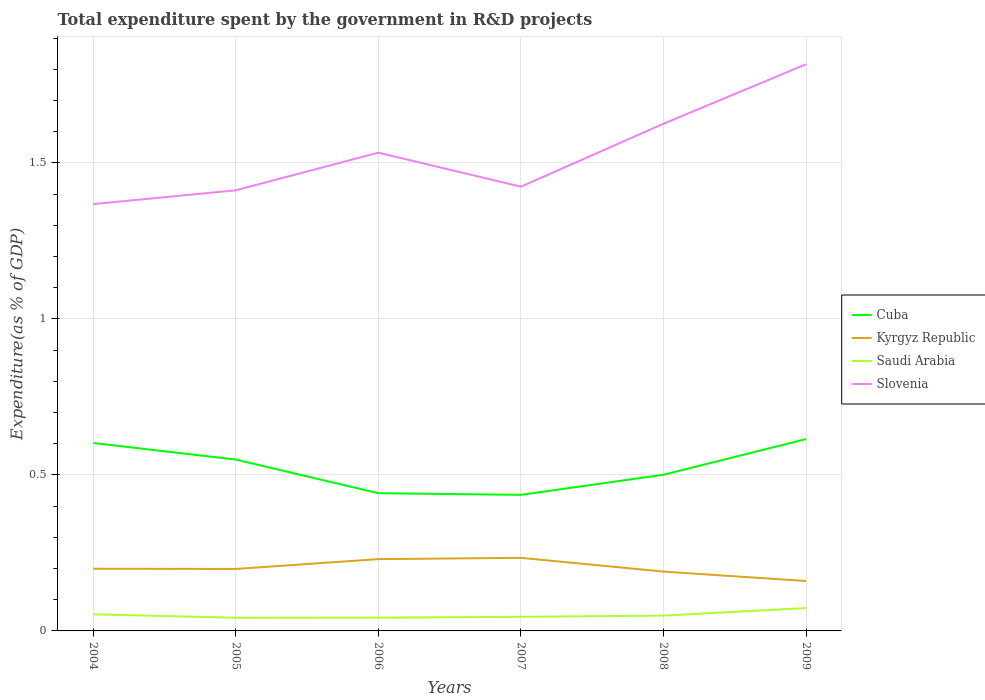Does the line corresponding to Saudi Arabia intersect with the line corresponding to Kyrgyz Republic?
Keep it short and to the point. No. Is the number of lines equal to the number of legend labels?
Make the answer very short. Yes. Across all years, what is the maximum total expenditure spent by the government in R&D projects in Saudi Arabia?
Provide a short and direct response. 0.04. What is the total total expenditure spent by the government in R&D projects in Saudi Arabia in the graph?
Provide a succinct answer. 0.01. What is the difference between the highest and the second highest total expenditure spent by the government in R&D projects in Kyrgyz Republic?
Keep it short and to the point. 0.07. Is the total expenditure spent by the government in R&D projects in Slovenia strictly greater than the total expenditure spent by the government in R&D projects in Cuba over the years?
Make the answer very short. No. How many years are there in the graph?
Ensure brevity in your answer.  6. What is the difference between two consecutive major ticks on the Y-axis?
Offer a very short reply. 0.5. Are the values on the major ticks of Y-axis written in scientific E-notation?
Your answer should be compact. No. Does the graph contain grids?
Your response must be concise. Yes. Where does the legend appear in the graph?
Provide a short and direct response. Center right. How many legend labels are there?
Your answer should be compact. 4. What is the title of the graph?
Give a very brief answer. Total expenditure spent by the government in R&D projects. Does "Kosovo" appear as one of the legend labels in the graph?
Make the answer very short. No. What is the label or title of the Y-axis?
Your response must be concise. Expenditure(as % of GDP). What is the Expenditure(as % of GDP) in Cuba in 2004?
Provide a short and direct response. 0.6. What is the Expenditure(as % of GDP) of Kyrgyz Republic in 2004?
Keep it short and to the point. 0.2. What is the Expenditure(as % of GDP) in Saudi Arabia in 2004?
Make the answer very short. 0.05. What is the Expenditure(as % of GDP) in Slovenia in 2004?
Your response must be concise. 1.37. What is the Expenditure(as % of GDP) in Cuba in 2005?
Offer a terse response. 0.55. What is the Expenditure(as % of GDP) in Kyrgyz Republic in 2005?
Offer a terse response. 0.2. What is the Expenditure(as % of GDP) of Saudi Arabia in 2005?
Your answer should be very brief. 0.04. What is the Expenditure(as % of GDP) of Slovenia in 2005?
Offer a terse response. 1.41. What is the Expenditure(as % of GDP) of Cuba in 2006?
Your answer should be compact. 0.44. What is the Expenditure(as % of GDP) in Kyrgyz Republic in 2006?
Give a very brief answer. 0.23. What is the Expenditure(as % of GDP) of Saudi Arabia in 2006?
Ensure brevity in your answer.  0.04. What is the Expenditure(as % of GDP) of Slovenia in 2006?
Give a very brief answer. 1.53. What is the Expenditure(as % of GDP) in Cuba in 2007?
Make the answer very short. 0.44. What is the Expenditure(as % of GDP) of Kyrgyz Republic in 2007?
Your answer should be very brief. 0.23. What is the Expenditure(as % of GDP) of Saudi Arabia in 2007?
Offer a very short reply. 0.05. What is the Expenditure(as % of GDP) in Slovenia in 2007?
Ensure brevity in your answer.  1.42. What is the Expenditure(as % of GDP) in Cuba in 2008?
Make the answer very short. 0.5. What is the Expenditure(as % of GDP) in Kyrgyz Republic in 2008?
Offer a terse response. 0.19. What is the Expenditure(as % of GDP) in Saudi Arabia in 2008?
Ensure brevity in your answer.  0.05. What is the Expenditure(as % of GDP) of Slovenia in 2008?
Provide a short and direct response. 1.63. What is the Expenditure(as % of GDP) of Cuba in 2009?
Provide a succinct answer. 0.61. What is the Expenditure(as % of GDP) of Kyrgyz Republic in 2009?
Offer a terse response. 0.16. What is the Expenditure(as % of GDP) of Saudi Arabia in 2009?
Ensure brevity in your answer.  0.07. What is the Expenditure(as % of GDP) of Slovenia in 2009?
Make the answer very short. 1.82. Across all years, what is the maximum Expenditure(as % of GDP) of Cuba?
Give a very brief answer. 0.61. Across all years, what is the maximum Expenditure(as % of GDP) of Kyrgyz Republic?
Offer a very short reply. 0.23. Across all years, what is the maximum Expenditure(as % of GDP) in Saudi Arabia?
Your answer should be very brief. 0.07. Across all years, what is the maximum Expenditure(as % of GDP) in Slovenia?
Provide a succinct answer. 1.82. Across all years, what is the minimum Expenditure(as % of GDP) in Cuba?
Provide a short and direct response. 0.44. Across all years, what is the minimum Expenditure(as % of GDP) in Kyrgyz Republic?
Keep it short and to the point. 0.16. Across all years, what is the minimum Expenditure(as % of GDP) of Saudi Arabia?
Provide a succinct answer. 0.04. Across all years, what is the minimum Expenditure(as % of GDP) in Slovenia?
Provide a succinct answer. 1.37. What is the total Expenditure(as % of GDP) in Cuba in the graph?
Your answer should be very brief. 3.14. What is the total Expenditure(as % of GDP) of Kyrgyz Republic in the graph?
Offer a very short reply. 1.21. What is the total Expenditure(as % of GDP) in Saudi Arabia in the graph?
Keep it short and to the point. 0.31. What is the total Expenditure(as % of GDP) of Slovenia in the graph?
Give a very brief answer. 9.18. What is the difference between the Expenditure(as % of GDP) of Cuba in 2004 and that in 2005?
Your answer should be compact. 0.05. What is the difference between the Expenditure(as % of GDP) in Kyrgyz Republic in 2004 and that in 2005?
Offer a very short reply. 0. What is the difference between the Expenditure(as % of GDP) of Saudi Arabia in 2004 and that in 2005?
Offer a terse response. 0.01. What is the difference between the Expenditure(as % of GDP) of Slovenia in 2004 and that in 2005?
Ensure brevity in your answer.  -0.04. What is the difference between the Expenditure(as % of GDP) in Cuba in 2004 and that in 2006?
Offer a terse response. 0.16. What is the difference between the Expenditure(as % of GDP) of Kyrgyz Republic in 2004 and that in 2006?
Give a very brief answer. -0.03. What is the difference between the Expenditure(as % of GDP) in Saudi Arabia in 2004 and that in 2006?
Ensure brevity in your answer.  0.01. What is the difference between the Expenditure(as % of GDP) of Slovenia in 2004 and that in 2006?
Offer a very short reply. -0.16. What is the difference between the Expenditure(as % of GDP) of Cuba in 2004 and that in 2007?
Give a very brief answer. 0.17. What is the difference between the Expenditure(as % of GDP) in Kyrgyz Republic in 2004 and that in 2007?
Give a very brief answer. -0.04. What is the difference between the Expenditure(as % of GDP) in Saudi Arabia in 2004 and that in 2007?
Offer a very short reply. 0.01. What is the difference between the Expenditure(as % of GDP) of Slovenia in 2004 and that in 2007?
Make the answer very short. -0.06. What is the difference between the Expenditure(as % of GDP) in Cuba in 2004 and that in 2008?
Provide a short and direct response. 0.1. What is the difference between the Expenditure(as % of GDP) in Kyrgyz Republic in 2004 and that in 2008?
Make the answer very short. 0.01. What is the difference between the Expenditure(as % of GDP) in Saudi Arabia in 2004 and that in 2008?
Ensure brevity in your answer.  0. What is the difference between the Expenditure(as % of GDP) of Slovenia in 2004 and that in 2008?
Provide a succinct answer. -0.26. What is the difference between the Expenditure(as % of GDP) of Cuba in 2004 and that in 2009?
Your answer should be very brief. -0.01. What is the difference between the Expenditure(as % of GDP) in Kyrgyz Republic in 2004 and that in 2009?
Your answer should be very brief. 0.04. What is the difference between the Expenditure(as % of GDP) of Saudi Arabia in 2004 and that in 2009?
Your response must be concise. -0.02. What is the difference between the Expenditure(as % of GDP) in Slovenia in 2004 and that in 2009?
Ensure brevity in your answer.  -0.45. What is the difference between the Expenditure(as % of GDP) of Cuba in 2005 and that in 2006?
Your answer should be very brief. 0.11. What is the difference between the Expenditure(as % of GDP) in Kyrgyz Republic in 2005 and that in 2006?
Give a very brief answer. -0.03. What is the difference between the Expenditure(as % of GDP) in Saudi Arabia in 2005 and that in 2006?
Your answer should be very brief. -0. What is the difference between the Expenditure(as % of GDP) of Slovenia in 2005 and that in 2006?
Give a very brief answer. -0.12. What is the difference between the Expenditure(as % of GDP) of Cuba in 2005 and that in 2007?
Your answer should be very brief. 0.11. What is the difference between the Expenditure(as % of GDP) of Kyrgyz Republic in 2005 and that in 2007?
Give a very brief answer. -0.04. What is the difference between the Expenditure(as % of GDP) in Saudi Arabia in 2005 and that in 2007?
Provide a succinct answer. -0. What is the difference between the Expenditure(as % of GDP) in Slovenia in 2005 and that in 2007?
Give a very brief answer. -0.01. What is the difference between the Expenditure(as % of GDP) of Cuba in 2005 and that in 2008?
Provide a succinct answer. 0.05. What is the difference between the Expenditure(as % of GDP) of Kyrgyz Republic in 2005 and that in 2008?
Your response must be concise. 0.01. What is the difference between the Expenditure(as % of GDP) in Saudi Arabia in 2005 and that in 2008?
Offer a very short reply. -0.01. What is the difference between the Expenditure(as % of GDP) of Slovenia in 2005 and that in 2008?
Your answer should be compact. -0.21. What is the difference between the Expenditure(as % of GDP) in Cuba in 2005 and that in 2009?
Your answer should be very brief. -0.07. What is the difference between the Expenditure(as % of GDP) of Kyrgyz Republic in 2005 and that in 2009?
Keep it short and to the point. 0.04. What is the difference between the Expenditure(as % of GDP) of Saudi Arabia in 2005 and that in 2009?
Provide a succinct answer. -0.03. What is the difference between the Expenditure(as % of GDP) of Slovenia in 2005 and that in 2009?
Your response must be concise. -0.4. What is the difference between the Expenditure(as % of GDP) in Cuba in 2006 and that in 2007?
Provide a succinct answer. 0.01. What is the difference between the Expenditure(as % of GDP) of Kyrgyz Republic in 2006 and that in 2007?
Offer a terse response. -0. What is the difference between the Expenditure(as % of GDP) of Saudi Arabia in 2006 and that in 2007?
Give a very brief answer. -0. What is the difference between the Expenditure(as % of GDP) of Slovenia in 2006 and that in 2007?
Make the answer very short. 0.11. What is the difference between the Expenditure(as % of GDP) of Cuba in 2006 and that in 2008?
Your response must be concise. -0.06. What is the difference between the Expenditure(as % of GDP) in Saudi Arabia in 2006 and that in 2008?
Provide a short and direct response. -0.01. What is the difference between the Expenditure(as % of GDP) in Slovenia in 2006 and that in 2008?
Provide a short and direct response. -0.09. What is the difference between the Expenditure(as % of GDP) in Cuba in 2006 and that in 2009?
Your answer should be very brief. -0.17. What is the difference between the Expenditure(as % of GDP) in Kyrgyz Republic in 2006 and that in 2009?
Provide a short and direct response. 0.07. What is the difference between the Expenditure(as % of GDP) in Saudi Arabia in 2006 and that in 2009?
Ensure brevity in your answer.  -0.03. What is the difference between the Expenditure(as % of GDP) in Slovenia in 2006 and that in 2009?
Ensure brevity in your answer.  -0.28. What is the difference between the Expenditure(as % of GDP) of Cuba in 2007 and that in 2008?
Give a very brief answer. -0.06. What is the difference between the Expenditure(as % of GDP) in Kyrgyz Republic in 2007 and that in 2008?
Offer a terse response. 0.04. What is the difference between the Expenditure(as % of GDP) in Saudi Arabia in 2007 and that in 2008?
Give a very brief answer. -0. What is the difference between the Expenditure(as % of GDP) of Slovenia in 2007 and that in 2008?
Provide a succinct answer. -0.2. What is the difference between the Expenditure(as % of GDP) in Cuba in 2007 and that in 2009?
Ensure brevity in your answer.  -0.18. What is the difference between the Expenditure(as % of GDP) of Kyrgyz Republic in 2007 and that in 2009?
Your response must be concise. 0.07. What is the difference between the Expenditure(as % of GDP) in Saudi Arabia in 2007 and that in 2009?
Keep it short and to the point. -0.03. What is the difference between the Expenditure(as % of GDP) in Slovenia in 2007 and that in 2009?
Keep it short and to the point. -0.39. What is the difference between the Expenditure(as % of GDP) of Cuba in 2008 and that in 2009?
Offer a terse response. -0.11. What is the difference between the Expenditure(as % of GDP) in Kyrgyz Republic in 2008 and that in 2009?
Make the answer very short. 0.03. What is the difference between the Expenditure(as % of GDP) in Saudi Arabia in 2008 and that in 2009?
Give a very brief answer. -0.02. What is the difference between the Expenditure(as % of GDP) in Slovenia in 2008 and that in 2009?
Provide a short and direct response. -0.19. What is the difference between the Expenditure(as % of GDP) in Cuba in 2004 and the Expenditure(as % of GDP) in Kyrgyz Republic in 2005?
Provide a short and direct response. 0.4. What is the difference between the Expenditure(as % of GDP) in Cuba in 2004 and the Expenditure(as % of GDP) in Saudi Arabia in 2005?
Offer a terse response. 0.56. What is the difference between the Expenditure(as % of GDP) in Cuba in 2004 and the Expenditure(as % of GDP) in Slovenia in 2005?
Offer a terse response. -0.81. What is the difference between the Expenditure(as % of GDP) in Kyrgyz Republic in 2004 and the Expenditure(as % of GDP) in Saudi Arabia in 2005?
Your answer should be very brief. 0.16. What is the difference between the Expenditure(as % of GDP) in Kyrgyz Republic in 2004 and the Expenditure(as % of GDP) in Slovenia in 2005?
Offer a very short reply. -1.21. What is the difference between the Expenditure(as % of GDP) of Saudi Arabia in 2004 and the Expenditure(as % of GDP) of Slovenia in 2005?
Make the answer very short. -1.36. What is the difference between the Expenditure(as % of GDP) in Cuba in 2004 and the Expenditure(as % of GDP) in Kyrgyz Republic in 2006?
Your response must be concise. 0.37. What is the difference between the Expenditure(as % of GDP) in Cuba in 2004 and the Expenditure(as % of GDP) in Saudi Arabia in 2006?
Offer a very short reply. 0.56. What is the difference between the Expenditure(as % of GDP) in Cuba in 2004 and the Expenditure(as % of GDP) in Slovenia in 2006?
Give a very brief answer. -0.93. What is the difference between the Expenditure(as % of GDP) in Kyrgyz Republic in 2004 and the Expenditure(as % of GDP) in Saudi Arabia in 2006?
Give a very brief answer. 0.16. What is the difference between the Expenditure(as % of GDP) of Kyrgyz Republic in 2004 and the Expenditure(as % of GDP) of Slovenia in 2006?
Keep it short and to the point. -1.33. What is the difference between the Expenditure(as % of GDP) of Saudi Arabia in 2004 and the Expenditure(as % of GDP) of Slovenia in 2006?
Keep it short and to the point. -1.48. What is the difference between the Expenditure(as % of GDP) in Cuba in 2004 and the Expenditure(as % of GDP) in Kyrgyz Republic in 2007?
Your answer should be very brief. 0.37. What is the difference between the Expenditure(as % of GDP) in Cuba in 2004 and the Expenditure(as % of GDP) in Saudi Arabia in 2007?
Provide a short and direct response. 0.56. What is the difference between the Expenditure(as % of GDP) of Cuba in 2004 and the Expenditure(as % of GDP) of Slovenia in 2007?
Offer a very short reply. -0.82. What is the difference between the Expenditure(as % of GDP) of Kyrgyz Republic in 2004 and the Expenditure(as % of GDP) of Saudi Arabia in 2007?
Your response must be concise. 0.15. What is the difference between the Expenditure(as % of GDP) of Kyrgyz Republic in 2004 and the Expenditure(as % of GDP) of Slovenia in 2007?
Ensure brevity in your answer.  -1.22. What is the difference between the Expenditure(as % of GDP) in Saudi Arabia in 2004 and the Expenditure(as % of GDP) in Slovenia in 2007?
Offer a very short reply. -1.37. What is the difference between the Expenditure(as % of GDP) of Cuba in 2004 and the Expenditure(as % of GDP) of Kyrgyz Republic in 2008?
Make the answer very short. 0.41. What is the difference between the Expenditure(as % of GDP) in Cuba in 2004 and the Expenditure(as % of GDP) in Saudi Arabia in 2008?
Ensure brevity in your answer.  0.55. What is the difference between the Expenditure(as % of GDP) of Cuba in 2004 and the Expenditure(as % of GDP) of Slovenia in 2008?
Give a very brief answer. -1.02. What is the difference between the Expenditure(as % of GDP) of Kyrgyz Republic in 2004 and the Expenditure(as % of GDP) of Saudi Arabia in 2008?
Offer a very short reply. 0.15. What is the difference between the Expenditure(as % of GDP) in Kyrgyz Republic in 2004 and the Expenditure(as % of GDP) in Slovenia in 2008?
Your answer should be compact. -1.43. What is the difference between the Expenditure(as % of GDP) of Saudi Arabia in 2004 and the Expenditure(as % of GDP) of Slovenia in 2008?
Provide a succinct answer. -1.57. What is the difference between the Expenditure(as % of GDP) of Cuba in 2004 and the Expenditure(as % of GDP) of Kyrgyz Republic in 2009?
Your answer should be very brief. 0.44. What is the difference between the Expenditure(as % of GDP) of Cuba in 2004 and the Expenditure(as % of GDP) of Saudi Arabia in 2009?
Provide a short and direct response. 0.53. What is the difference between the Expenditure(as % of GDP) in Cuba in 2004 and the Expenditure(as % of GDP) in Slovenia in 2009?
Provide a short and direct response. -1.21. What is the difference between the Expenditure(as % of GDP) of Kyrgyz Republic in 2004 and the Expenditure(as % of GDP) of Saudi Arabia in 2009?
Provide a succinct answer. 0.13. What is the difference between the Expenditure(as % of GDP) in Kyrgyz Republic in 2004 and the Expenditure(as % of GDP) in Slovenia in 2009?
Your answer should be compact. -1.62. What is the difference between the Expenditure(as % of GDP) of Saudi Arabia in 2004 and the Expenditure(as % of GDP) of Slovenia in 2009?
Provide a short and direct response. -1.76. What is the difference between the Expenditure(as % of GDP) of Cuba in 2005 and the Expenditure(as % of GDP) of Kyrgyz Republic in 2006?
Your response must be concise. 0.32. What is the difference between the Expenditure(as % of GDP) of Cuba in 2005 and the Expenditure(as % of GDP) of Saudi Arabia in 2006?
Provide a succinct answer. 0.51. What is the difference between the Expenditure(as % of GDP) in Cuba in 2005 and the Expenditure(as % of GDP) in Slovenia in 2006?
Your answer should be compact. -0.98. What is the difference between the Expenditure(as % of GDP) of Kyrgyz Republic in 2005 and the Expenditure(as % of GDP) of Saudi Arabia in 2006?
Offer a very short reply. 0.16. What is the difference between the Expenditure(as % of GDP) of Kyrgyz Republic in 2005 and the Expenditure(as % of GDP) of Slovenia in 2006?
Your response must be concise. -1.33. What is the difference between the Expenditure(as % of GDP) of Saudi Arabia in 2005 and the Expenditure(as % of GDP) of Slovenia in 2006?
Provide a short and direct response. -1.49. What is the difference between the Expenditure(as % of GDP) of Cuba in 2005 and the Expenditure(as % of GDP) of Kyrgyz Republic in 2007?
Ensure brevity in your answer.  0.32. What is the difference between the Expenditure(as % of GDP) in Cuba in 2005 and the Expenditure(as % of GDP) in Saudi Arabia in 2007?
Offer a very short reply. 0.5. What is the difference between the Expenditure(as % of GDP) in Cuba in 2005 and the Expenditure(as % of GDP) in Slovenia in 2007?
Your answer should be very brief. -0.87. What is the difference between the Expenditure(as % of GDP) of Kyrgyz Republic in 2005 and the Expenditure(as % of GDP) of Saudi Arabia in 2007?
Give a very brief answer. 0.15. What is the difference between the Expenditure(as % of GDP) in Kyrgyz Republic in 2005 and the Expenditure(as % of GDP) in Slovenia in 2007?
Your answer should be compact. -1.23. What is the difference between the Expenditure(as % of GDP) of Saudi Arabia in 2005 and the Expenditure(as % of GDP) of Slovenia in 2007?
Your answer should be compact. -1.38. What is the difference between the Expenditure(as % of GDP) of Cuba in 2005 and the Expenditure(as % of GDP) of Kyrgyz Republic in 2008?
Provide a succinct answer. 0.36. What is the difference between the Expenditure(as % of GDP) in Cuba in 2005 and the Expenditure(as % of GDP) in Saudi Arabia in 2008?
Your answer should be very brief. 0.5. What is the difference between the Expenditure(as % of GDP) in Cuba in 2005 and the Expenditure(as % of GDP) in Slovenia in 2008?
Offer a very short reply. -1.08. What is the difference between the Expenditure(as % of GDP) of Kyrgyz Republic in 2005 and the Expenditure(as % of GDP) of Saudi Arabia in 2008?
Provide a short and direct response. 0.15. What is the difference between the Expenditure(as % of GDP) in Kyrgyz Republic in 2005 and the Expenditure(as % of GDP) in Slovenia in 2008?
Keep it short and to the point. -1.43. What is the difference between the Expenditure(as % of GDP) in Saudi Arabia in 2005 and the Expenditure(as % of GDP) in Slovenia in 2008?
Keep it short and to the point. -1.58. What is the difference between the Expenditure(as % of GDP) of Cuba in 2005 and the Expenditure(as % of GDP) of Kyrgyz Republic in 2009?
Your answer should be very brief. 0.39. What is the difference between the Expenditure(as % of GDP) in Cuba in 2005 and the Expenditure(as % of GDP) in Saudi Arabia in 2009?
Provide a succinct answer. 0.48. What is the difference between the Expenditure(as % of GDP) in Cuba in 2005 and the Expenditure(as % of GDP) in Slovenia in 2009?
Keep it short and to the point. -1.27. What is the difference between the Expenditure(as % of GDP) in Kyrgyz Republic in 2005 and the Expenditure(as % of GDP) in Saudi Arabia in 2009?
Keep it short and to the point. 0.13. What is the difference between the Expenditure(as % of GDP) in Kyrgyz Republic in 2005 and the Expenditure(as % of GDP) in Slovenia in 2009?
Make the answer very short. -1.62. What is the difference between the Expenditure(as % of GDP) in Saudi Arabia in 2005 and the Expenditure(as % of GDP) in Slovenia in 2009?
Your answer should be compact. -1.77. What is the difference between the Expenditure(as % of GDP) of Cuba in 2006 and the Expenditure(as % of GDP) of Kyrgyz Republic in 2007?
Give a very brief answer. 0.21. What is the difference between the Expenditure(as % of GDP) in Cuba in 2006 and the Expenditure(as % of GDP) in Saudi Arabia in 2007?
Your response must be concise. 0.4. What is the difference between the Expenditure(as % of GDP) of Cuba in 2006 and the Expenditure(as % of GDP) of Slovenia in 2007?
Offer a very short reply. -0.98. What is the difference between the Expenditure(as % of GDP) in Kyrgyz Republic in 2006 and the Expenditure(as % of GDP) in Saudi Arabia in 2007?
Your answer should be very brief. 0.18. What is the difference between the Expenditure(as % of GDP) in Kyrgyz Republic in 2006 and the Expenditure(as % of GDP) in Slovenia in 2007?
Offer a terse response. -1.19. What is the difference between the Expenditure(as % of GDP) in Saudi Arabia in 2006 and the Expenditure(as % of GDP) in Slovenia in 2007?
Give a very brief answer. -1.38. What is the difference between the Expenditure(as % of GDP) in Cuba in 2006 and the Expenditure(as % of GDP) in Kyrgyz Republic in 2008?
Make the answer very short. 0.25. What is the difference between the Expenditure(as % of GDP) of Cuba in 2006 and the Expenditure(as % of GDP) of Saudi Arabia in 2008?
Your answer should be compact. 0.39. What is the difference between the Expenditure(as % of GDP) of Cuba in 2006 and the Expenditure(as % of GDP) of Slovenia in 2008?
Your answer should be very brief. -1.18. What is the difference between the Expenditure(as % of GDP) of Kyrgyz Republic in 2006 and the Expenditure(as % of GDP) of Saudi Arabia in 2008?
Your response must be concise. 0.18. What is the difference between the Expenditure(as % of GDP) in Kyrgyz Republic in 2006 and the Expenditure(as % of GDP) in Slovenia in 2008?
Provide a short and direct response. -1.4. What is the difference between the Expenditure(as % of GDP) in Saudi Arabia in 2006 and the Expenditure(as % of GDP) in Slovenia in 2008?
Offer a very short reply. -1.58. What is the difference between the Expenditure(as % of GDP) in Cuba in 2006 and the Expenditure(as % of GDP) in Kyrgyz Republic in 2009?
Provide a short and direct response. 0.28. What is the difference between the Expenditure(as % of GDP) of Cuba in 2006 and the Expenditure(as % of GDP) of Saudi Arabia in 2009?
Make the answer very short. 0.37. What is the difference between the Expenditure(as % of GDP) of Cuba in 2006 and the Expenditure(as % of GDP) of Slovenia in 2009?
Offer a terse response. -1.37. What is the difference between the Expenditure(as % of GDP) of Kyrgyz Republic in 2006 and the Expenditure(as % of GDP) of Saudi Arabia in 2009?
Give a very brief answer. 0.16. What is the difference between the Expenditure(as % of GDP) of Kyrgyz Republic in 2006 and the Expenditure(as % of GDP) of Slovenia in 2009?
Your answer should be compact. -1.59. What is the difference between the Expenditure(as % of GDP) of Saudi Arabia in 2006 and the Expenditure(as % of GDP) of Slovenia in 2009?
Provide a short and direct response. -1.77. What is the difference between the Expenditure(as % of GDP) in Cuba in 2007 and the Expenditure(as % of GDP) in Kyrgyz Republic in 2008?
Make the answer very short. 0.25. What is the difference between the Expenditure(as % of GDP) in Cuba in 2007 and the Expenditure(as % of GDP) in Saudi Arabia in 2008?
Your answer should be very brief. 0.39. What is the difference between the Expenditure(as % of GDP) of Cuba in 2007 and the Expenditure(as % of GDP) of Slovenia in 2008?
Ensure brevity in your answer.  -1.19. What is the difference between the Expenditure(as % of GDP) in Kyrgyz Republic in 2007 and the Expenditure(as % of GDP) in Saudi Arabia in 2008?
Give a very brief answer. 0.19. What is the difference between the Expenditure(as % of GDP) in Kyrgyz Republic in 2007 and the Expenditure(as % of GDP) in Slovenia in 2008?
Offer a very short reply. -1.39. What is the difference between the Expenditure(as % of GDP) in Saudi Arabia in 2007 and the Expenditure(as % of GDP) in Slovenia in 2008?
Provide a succinct answer. -1.58. What is the difference between the Expenditure(as % of GDP) in Cuba in 2007 and the Expenditure(as % of GDP) in Kyrgyz Republic in 2009?
Offer a terse response. 0.28. What is the difference between the Expenditure(as % of GDP) of Cuba in 2007 and the Expenditure(as % of GDP) of Saudi Arabia in 2009?
Give a very brief answer. 0.36. What is the difference between the Expenditure(as % of GDP) in Cuba in 2007 and the Expenditure(as % of GDP) in Slovenia in 2009?
Keep it short and to the point. -1.38. What is the difference between the Expenditure(as % of GDP) of Kyrgyz Republic in 2007 and the Expenditure(as % of GDP) of Saudi Arabia in 2009?
Provide a succinct answer. 0.16. What is the difference between the Expenditure(as % of GDP) in Kyrgyz Republic in 2007 and the Expenditure(as % of GDP) in Slovenia in 2009?
Your response must be concise. -1.58. What is the difference between the Expenditure(as % of GDP) of Saudi Arabia in 2007 and the Expenditure(as % of GDP) of Slovenia in 2009?
Offer a terse response. -1.77. What is the difference between the Expenditure(as % of GDP) of Cuba in 2008 and the Expenditure(as % of GDP) of Kyrgyz Republic in 2009?
Your answer should be compact. 0.34. What is the difference between the Expenditure(as % of GDP) in Cuba in 2008 and the Expenditure(as % of GDP) in Saudi Arabia in 2009?
Ensure brevity in your answer.  0.43. What is the difference between the Expenditure(as % of GDP) in Cuba in 2008 and the Expenditure(as % of GDP) in Slovenia in 2009?
Provide a short and direct response. -1.32. What is the difference between the Expenditure(as % of GDP) of Kyrgyz Republic in 2008 and the Expenditure(as % of GDP) of Saudi Arabia in 2009?
Make the answer very short. 0.12. What is the difference between the Expenditure(as % of GDP) in Kyrgyz Republic in 2008 and the Expenditure(as % of GDP) in Slovenia in 2009?
Give a very brief answer. -1.63. What is the difference between the Expenditure(as % of GDP) of Saudi Arabia in 2008 and the Expenditure(as % of GDP) of Slovenia in 2009?
Ensure brevity in your answer.  -1.77. What is the average Expenditure(as % of GDP) in Cuba per year?
Ensure brevity in your answer.  0.52. What is the average Expenditure(as % of GDP) of Kyrgyz Republic per year?
Your response must be concise. 0.2. What is the average Expenditure(as % of GDP) in Saudi Arabia per year?
Your answer should be compact. 0.05. What is the average Expenditure(as % of GDP) in Slovenia per year?
Offer a very short reply. 1.53. In the year 2004, what is the difference between the Expenditure(as % of GDP) of Cuba and Expenditure(as % of GDP) of Kyrgyz Republic?
Give a very brief answer. 0.4. In the year 2004, what is the difference between the Expenditure(as % of GDP) of Cuba and Expenditure(as % of GDP) of Saudi Arabia?
Your response must be concise. 0.55. In the year 2004, what is the difference between the Expenditure(as % of GDP) of Cuba and Expenditure(as % of GDP) of Slovenia?
Your answer should be very brief. -0.77. In the year 2004, what is the difference between the Expenditure(as % of GDP) in Kyrgyz Republic and Expenditure(as % of GDP) in Saudi Arabia?
Your answer should be compact. 0.15. In the year 2004, what is the difference between the Expenditure(as % of GDP) of Kyrgyz Republic and Expenditure(as % of GDP) of Slovenia?
Make the answer very short. -1.17. In the year 2004, what is the difference between the Expenditure(as % of GDP) in Saudi Arabia and Expenditure(as % of GDP) in Slovenia?
Your answer should be very brief. -1.31. In the year 2005, what is the difference between the Expenditure(as % of GDP) of Cuba and Expenditure(as % of GDP) of Kyrgyz Republic?
Give a very brief answer. 0.35. In the year 2005, what is the difference between the Expenditure(as % of GDP) of Cuba and Expenditure(as % of GDP) of Saudi Arabia?
Offer a terse response. 0.51. In the year 2005, what is the difference between the Expenditure(as % of GDP) of Cuba and Expenditure(as % of GDP) of Slovenia?
Your answer should be very brief. -0.86. In the year 2005, what is the difference between the Expenditure(as % of GDP) of Kyrgyz Republic and Expenditure(as % of GDP) of Saudi Arabia?
Offer a terse response. 0.16. In the year 2005, what is the difference between the Expenditure(as % of GDP) of Kyrgyz Republic and Expenditure(as % of GDP) of Slovenia?
Provide a short and direct response. -1.21. In the year 2005, what is the difference between the Expenditure(as % of GDP) of Saudi Arabia and Expenditure(as % of GDP) of Slovenia?
Provide a short and direct response. -1.37. In the year 2006, what is the difference between the Expenditure(as % of GDP) of Cuba and Expenditure(as % of GDP) of Kyrgyz Republic?
Give a very brief answer. 0.21. In the year 2006, what is the difference between the Expenditure(as % of GDP) of Cuba and Expenditure(as % of GDP) of Saudi Arabia?
Offer a terse response. 0.4. In the year 2006, what is the difference between the Expenditure(as % of GDP) in Cuba and Expenditure(as % of GDP) in Slovenia?
Offer a terse response. -1.09. In the year 2006, what is the difference between the Expenditure(as % of GDP) of Kyrgyz Republic and Expenditure(as % of GDP) of Saudi Arabia?
Provide a succinct answer. 0.19. In the year 2006, what is the difference between the Expenditure(as % of GDP) of Kyrgyz Republic and Expenditure(as % of GDP) of Slovenia?
Your answer should be very brief. -1.3. In the year 2006, what is the difference between the Expenditure(as % of GDP) of Saudi Arabia and Expenditure(as % of GDP) of Slovenia?
Keep it short and to the point. -1.49. In the year 2007, what is the difference between the Expenditure(as % of GDP) in Cuba and Expenditure(as % of GDP) in Kyrgyz Republic?
Offer a terse response. 0.2. In the year 2007, what is the difference between the Expenditure(as % of GDP) in Cuba and Expenditure(as % of GDP) in Saudi Arabia?
Provide a succinct answer. 0.39. In the year 2007, what is the difference between the Expenditure(as % of GDP) in Cuba and Expenditure(as % of GDP) in Slovenia?
Offer a terse response. -0.99. In the year 2007, what is the difference between the Expenditure(as % of GDP) in Kyrgyz Republic and Expenditure(as % of GDP) in Saudi Arabia?
Keep it short and to the point. 0.19. In the year 2007, what is the difference between the Expenditure(as % of GDP) of Kyrgyz Republic and Expenditure(as % of GDP) of Slovenia?
Your response must be concise. -1.19. In the year 2007, what is the difference between the Expenditure(as % of GDP) in Saudi Arabia and Expenditure(as % of GDP) in Slovenia?
Your answer should be very brief. -1.38. In the year 2008, what is the difference between the Expenditure(as % of GDP) of Cuba and Expenditure(as % of GDP) of Kyrgyz Republic?
Your answer should be very brief. 0.31. In the year 2008, what is the difference between the Expenditure(as % of GDP) of Cuba and Expenditure(as % of GDP) of Saudi Arabia?
Give a very brief answer. 0.45. In the year 2008, what is the difference between the Expenditure(as % of GDP) of Cuba and Expenditure(as % of GDP) of Slovenia?
Give a very brief answer. -1.12. In the year 2008, what is the difference between the Expenditure(as % of GDP) of Kyrgyz Republic and Expenditure(as % of GDP) of Saudi Arabia?
Make the answer very short. 0.14. In the year 2008, what is the difference between the Expenditure(as % of GDP) in Kyrgyz Republic and Expenditure(as % of GDP) in Slovenia?
Provide a short and direct response. -1.44. In the year 2008, what is the difference between the Expenditure(as % of GDP) in Saudi Arabia and Expenditure(as % of GDP) in Slovenia?
Ensure brevity in your answer.  -1.58. In the year 2009, what is the difference between the Expenditure(as % of GDP) in Cuba and Expenditure(as % of GDP) in Kyrgyz Republic?
Your answer should be compact. 0.45. In the year 2009, what is the difference between the Expenditure(as % of GDP) in Cuba and Expenditure(as % of GDP) in Saudi Arabia?
Keep it short and to the point. 0.54. In the year 2009, what is the difference between the Expenditure(as % of GDP) in Cuba and Expenditure(as % of GDP) in Slovenia?
Your answer should be very brief. -1.2. In the year 2009, what is the difference between the Expenditure(as % of GDP) in Kyrgyz Republic and Expenditure(as % of GDP) in Saudi Arabia?
Keep it short and to the point. 0.09. In the year 2009, what is the difference between the Expenditure(as % of GDP) in Kyrgyz Republic and Expenditure(as % of GDP) in Slovenia?
Give a very brief answer. -1.66. In the year 2009, what is the difference between the Expenditure(as % of GDP) of Saudi Arabia and Expenditure(as % of GDP) of Slovenia?
Give a very brief answer. -1.74. What is the ratio of the Expenditure(as % of GDP) in Cuba in 2004 to that in 2005?
Offer a very short reply. 1.1. What is the ratio of the Expenditure(as % of GDP) of Saudi Arabia in 2004 to that in 2005?
Ensure brevity in your answer.  1.26. What is the ratio of the Expenditure(as % of GDP) of Slovenia in 2004 to that in 2005?
Offer a very short reply. 0.97. What is the ratio of the Expenditure(as % of GDP) in Cuba in 2004 to that in 2006?
Your answer should be very brief. 1.36. What is the ratio of the Expenditure(as % of GDP) of Kyrgyz Republic in 2004 to that in 2006?
Your answer should be very brief. 0.87. What is the ratio of the Expenditure(as % of GDP) of Saudi Arabia in 2004 to that in 2006?
Provide a succinct answer. 1.25. What is the ratio of the Expenditure(as % of GDP) of Slovenia in 2004 to that in 2006?
Your answer should be compact. 0.89. What is the ratio of the Expenditure(as % of GDP) in Cuba in 2004 to that in 2007?
Provide a succinct answer. 1.38. What is the ratio of the Expenditure(as % of GDP) of Kyrgyz Republic in 2004 to that in 2007?
Make the answer very short. 0.85. What is the ratio of the Expenditure(as % of GDP) of Saudi Arabia in 2004 to that in 2007?
Give a very brief answer. 1.18. What is the ratio of the Expenditure(as % of GDP) in Slovenia in 2004 to that in 2007?
Make the answer very short. 0.96. What is the ratio of the Expenditure(as % of GDP) in Cuba in 2004 to that in 2008?
Give a very brief answer. 1.2. What is the ratio of the Expenditure(as % of GDP) in Kyrgyz Republic in 2004 to that in 2008?
Your response must be concise. 1.05. What is the ratio of the Expenditure(as % of GDP) in Saudi Arabia in 2004 to that in 2008?
Your response must be concise. 1.08. What is the ratio of the Expenditure(as % of GDP) in Slovenia in 2004 to that in 2008?
Provide a succinct answer. 0.84. What is the ratio of the Expenditure(as % of GDP) of Cuba in 2004 to that in 2009?
Ensure brevity in your answer.  0.98. What is the ratio of the Expenditure(as % of GDP) in Kyrgyz Republic in 2004 to that in 2009?
Ensure brevity in your answer.  1.25. What is the ratio of the Expenditure(as % of GDP) of Saudi Arabia in 2004 to that in 2009?
Your answer should be very brief. 0.72. What is the ratio of the Expenditure(as % of GDP) in Slovenia in 2004 to that in 2009?
Offer a very short reply. 0.75. What is the ratio of the Expenditure(as % of GDP) in Cuba in 2005 to that in 2006?
Provide a succinct answer. 1.24. What is the ratio of the Expenditure(as % of GDP) of Kyrgyz Republic in 2005 to that in 2006?
Your answer should be very brief. 0.86. What is the ratio of the Expenditure(as % of GDP) in Slovenia in 2005 to that in 2006?
Give a very brief answer. 0.92. What is the ratio of the Expenditure(as % of GDP) in Cuba in 2005 to that in 2007?
Ensure brevity in your answer.  1.26. What is the ratio of the Expenditure(as % of GDP) in Kyrgyz Republic in 2005 to that in 2007?
Your answer should be compact. 0.85. What is the ratio of the Expenditure(as % of GDP) of Saudi Arabia in 2005 to that in 2007?
Your answer should be compact. 0.94. What is the ratio of the Expenditure(as % of GDP) in Cuba in 2005 to that in 2008?
Offer a terse response. 1.1. What is the ratio of the Expenditure(as % of GDP) in Kyrgyz Republic in 2005 to that in 2008?
Give a very brief answer. 1.04. What is the ratio of the Expenditure(as % of GDP) in Saudi Arabia in 2005 to that in 2008?
Ensure brevity in your answer.  0.86. What is the ratio of the Expenditure(as % of GDP) of Slovenia in 2005 to that in 2008?
Provide a succinct answer. 0.87. What is the ratio of the Expenditure(as % of GDP) of Cuba in 2005 to that in 2009?
Your answer should be very brief. 0.89. What is the ratio of the Expenditure(as % of GDP) of Kyrgyz Republic in 2005 to that in 2009?
Keep it short and to the point. 1.24. What is the ratio of the Expenditure(as % of GDP) of Saudi Arabia in 2005 to that in 2009?
Your response must be concise. 0.58. What is the ratio of the Expenditure(as % of GDP) of Slovenia in 2005 to that in 2009?
Provide a short and direct response. 0.78. What is the ratio of the Expenditure(as % of GDP) in Kyrgyz Republic in 2006 to that in 2007?
Your answer should be very brief. 0.98. What is the ratio of the Expenditure(as % of GDP) in Saudi Arabia in 2006 to that in 2007?
Provide a short and direct response. 0.94. What is the ratio of the Expenditure(as % of GDP) of Slovenia in 2006 to that in 2007?
Your answer should be compact. 1.08. What is the ratio of the Expenditure(as % of GDP) in Cuba in 2006 to that in 2008?
Give a very brief answer. 0.88. What is the ratio of the Expenditure(as % of GDP) of Kyrgyz Republic in 2006 to that in 2008?
Ensure brevity in your answer.  1.21. What is the ratio of the Expenditure(as % of GDP) in Saudi Arabia in 2006 to that in 2008?
Give a very brief answer. 0.87. What is the ratio of the Expenditure(as % of GDP) in Slovenia in 2006 to that in 2008?
Ensure brevity in your answer.  0.94. What is the ratio of the Expenditure(as % of GDP) of Cuba in 2006 to that in 2009?
Offer a very short reply. 0.72. What is the ratio of the Expenditure(as % of GDP) in Kyrgyz Republic in 2006 to that in 2009?
Keep it short and to the point. 1.44. What is the ratio of the Expenditure(as % of GDP) of Saudi Arabia in 2006 to that in 2009?
Offer a terse response. 0.58. What is the ratio of the Expenditure(as % of GDP) in Slovenia in 2006 to that in 2009?
Your response must be concise. 0.84. What is the ratio of the Expenditure(as % of GDP) of Cuba in 2007 to that in 2008?
Keep it short and to the point. 0.87. What is the ratio of the Expenditure(as % of GDP) in Kyrgyz Republic in 2007 to that in 2008?
Keep it short and to the point. 1.23. What is the ratio of the Expenditure(as % of GDP) in Saudi Arabia in 2007 to that in 2008?
Your response must be concise. 0.92. What is the ratio of the Expenditure(as % of GDP) of Slovenia in 2007 to that in 2008?
Make the answer very short. 0.88. What is the ratio of the Expenditure(as % of GDP) of Cuba in 2007 to that in 2009?
Your response must be concise. 0.71. What is the ratio of the Expenditure(as % of GDP) in Kyrgyz Republic in 2007 to that in 2009?
Make the answer very short. 1.46. What is the ratio of the Expenditure(as % of GDP) of Saudi Arabia in 2007 to that in 2009?
Offer a very short reply. 0.62. What is the ratio of the Expenditure(as % of GDP) of Slovenia in 2007 to that in 2009?
Your answer should be very brief. 0.78. What is the ratio of the Expenditure(as % of GDP) in Cuba in 2008 to that in 2009?
Your response must be concise. 0.81. What is the ratio of the Expenditure(as % of GDP) of Kyrgyz Republic in 2008 to that in 2009?
Offer a terse response. 1.19. What is the ratio of the Expenditure(as % of GDP) in Saudi Arabia in 2008 to that in 2009?
Your response must be concise. 0.67. What is the ratio of the Expenditure(as % of GDP) of Slovenia in 2008 to that in 2009?
Offer a very short reply. 0.9. What is the difference between the highest and the second highest Expenditure(as % of GDP) in Cuba?
Offer a very short reply. 0.01. What is the difference between the highest and the second highest Expenditure(as % of GDP) in Kyrgyz Republic?
Offer a terse response. 0. What is the difference between the highest and the second highest Expenditure(as % of GDP) in Saudi Arabia?
Keep it short and to the point. 0.02. What is the difference between the highest and the second highest Expenditure(as % of GDP) in Slovenia?
Provide a succinct answer. 0.19. What is the difference between the highest and the lowest Expenditure(as % of GDP) of Cuba?
Give a very brief answer. 0.18. What is the difference between the highest and the lowest Expenditure(as % of GDP) of Kyrgyz Republic?
Ensure brevity in your answer.  0.07. What is the difference between the highest and the lowest Expenditure(as % of GDP) in Saudi Arabia?
Your response must be concise. 0.03. What is the difference between the highest and the lowest Expenditure(as % of GDP) of Slovenia?
Offer a terse response. 0.45. 